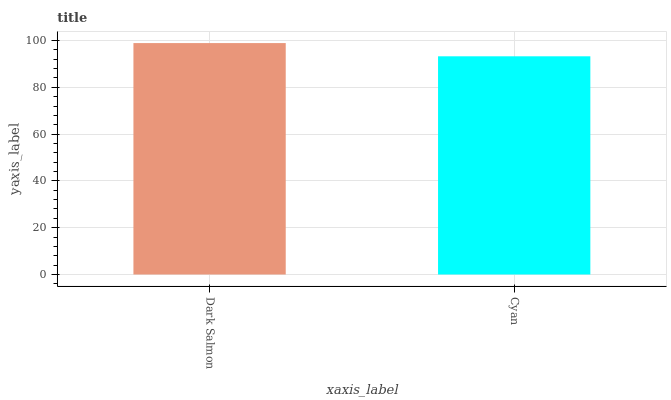Is Cyan the minimum?
Answer yes or no. Yes. Is Dark Salmon the maximum?
Answer yes or no. Yes. Is Cyan the maximum?
Answer yes or no. No. Is Dark Salmon greater than Cyan?
Answer yes or no. Yes. Is Cyan less than Dark Salmon?
Answer yes or no. Yes. Is Cyan greater than Dark Salmon?
Answer yes or no. No. Is Dark Salmon less than Cyan?
Answer yes or no. No. Is Dark Salmon the high median?
Answer yes or no. Yes. Is Cyan the low median?
Answer yes or no. Yes. Is Cyan the high median?
Answer yes or no. No. Is Dark Salmon the low median?
Answer yes or no. No. 